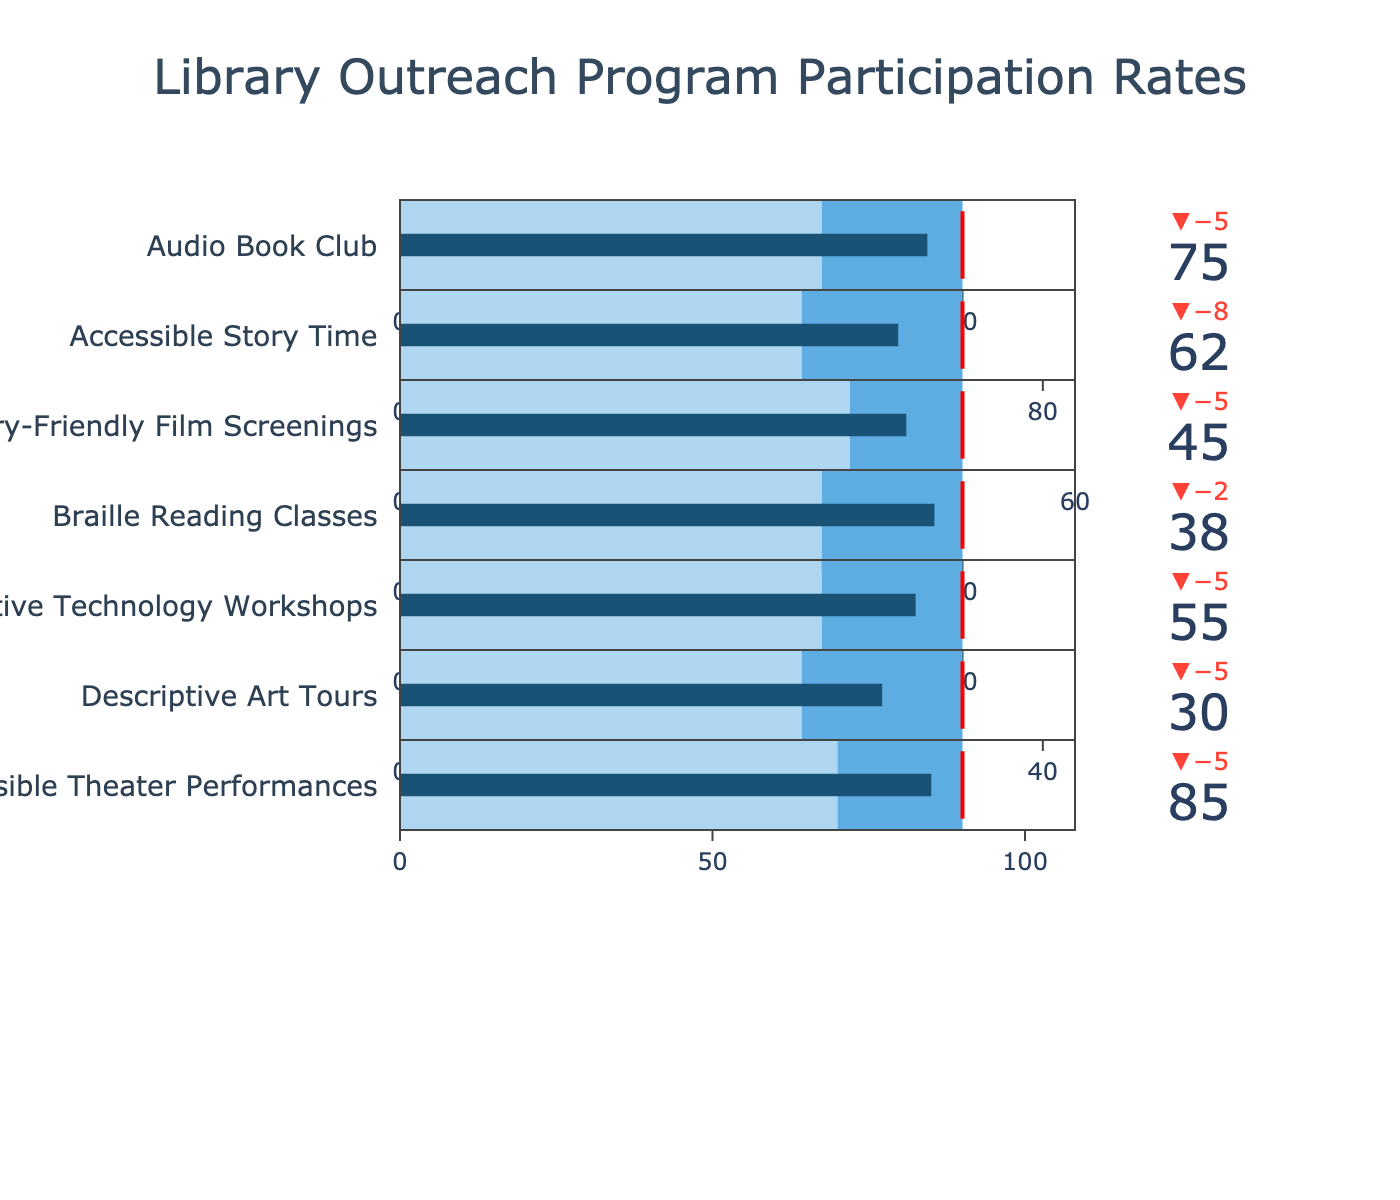What's the title of the chart? The title of the chart is displayed prominently at the top center of the figure. In this chart, it states the subject of the data visualized.
Answer: Library Outreach Program Participation Rates Which program had the highest actual participation rate? The program with the highest actual participation rate can be identified by examining the value bars in the bullet chart. The program with the tallest bar represents the highest participation rate.
Answer: Accessible Theater Performances What is the difference between the target and actual participation rates for the Descriptive Art Tours? To find the difference, subtract the actual participation rate of Descriptive Art Tours from its target participation rate.
Answer: 5 How many programs exceeded their benchmark participation rates? To determine this, look at each program and check if the actual participation rate bar extends beyond the benchmark range on the gauge. Count these instances.
Answer: 7 Among the programs that did not meet their targets, which one had the smallest shortfall? Compare the delta indicators of each program that did not hit their targets. The one with the smallest negative delta value has the smallest shortfall.
Answer: Sensory-Friendly Film Screenings How does the actual participation of the Braille Reading Classes compare to its benchmark? Check the position of the Braille Reading Classes' actual participation rate relative to the benchmark range on the bullet gauge.
Answer: 8 above Which program came closest to achieving its target, regardless of whether it met it or not? Examine the delta indicators for all programs to see which program has the smallest delta, whether positive or negative.
Answer: Accessible Story Time What is the average target participation rate across all programs? To calculate this, sum all target participation rates and divide by the number of programs. The programs and their targets are: 80, 70, 50, 40, 60, 35, 90. (80+70+50+40+60+35+90)/7 = 60.71
Answer: 60.71 Which program had the farthest discrepancy from its benchmark? Look for the program with the largest gap between its actual participation rate and its benchmark range, either above or below.
Answer: Audio Book Club 